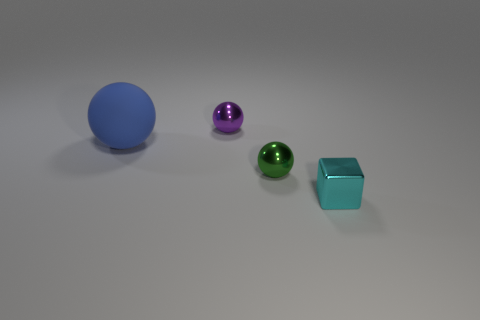Does the matte sphere have the same color as the shiny block?
Provide a succinct answer. No. How many other objects are there of the same shape as the cyan thing?
Ensure brevity in your answer.  0. Is the number of small metal cubes that are in front of the tiny shiny block greater than the number of tiny purple balls that are behind the purple sphere?
Make the answer very short. No. There is a ball that is on the right side of the tiny purple shiny ball; is its size the same as the shiny ball that is behind the big blue matte ball?
Your response must be concise. Yes. The small purple thing is what shape?
Your answer should be compact. Sphere. What is the color of the tiny cube that is the same material as the small green sphere?
Provide a short and direct response. Cyan. Do the purple sphere and the tiny ball in front of the large blue rubber ball have the same material?
Offer a very short reply. Yes. What is the color of the matte sphere?
Your answer should be compact. Blue. The purple object that is the same material as the block is what size?
Your answer should be very brief. Small. There is a metallic object in front of the metal ball in front of the big blue ball; how many cubes are in front of it?
Your response must be concise. 0. 